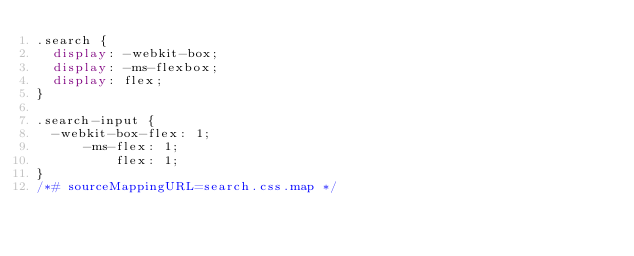Convert code to text. <code><loc_0><loc_0><loc_500><loc_500><_CSS_>.search {
  display: -webkit-box;
  display: -ms-flexbox;
  display: flex;
}

.search-input {
  -webkit-box-flex: 1;
      -ms-flex: 1;
          flex: 1;
}
/*# sourceMappingURL=search.css.map */</code> 